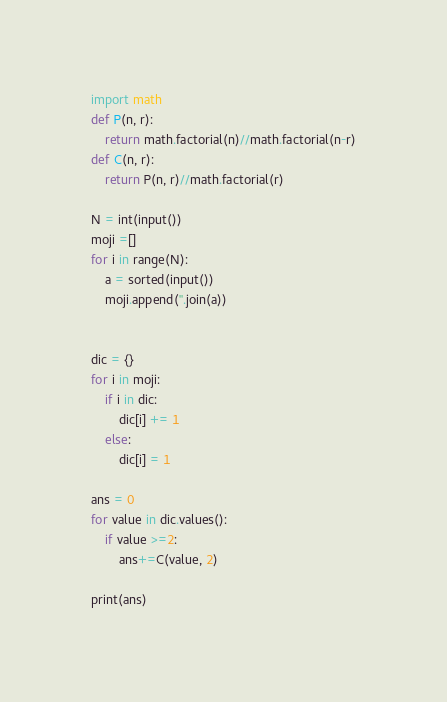Convert code to text. <code><loc_0><loc_0><loc_500><loc_500><_Python_>import math
def P(n, r):
    return math.factorial(n)//math.factorial(n-r)
def C(n, r):
    return P(n, r)//math.factorial(r)

N = int(input())
moji =[]
for i in range(N):
    a = sorted(input())
    moji.append(''.join(a))


dic = {}
for i in moji:
    if i in dic:
        dic[i] += 1
    else:
        dic[i] = 1

ans = 0
for value in dic.values():
    if value >=2:
        ans+=C(value, 2)

print(ans)</code> 